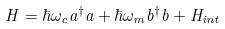Convert formula to latex. <formula><loc_0><loc_0><loc_500><loc_500>H = \hbar { \omega } _ { c } a ^ { \dag } a + \hbar { \omega } _ { m } b ^ { \dag } b + H _ { i n t }</formula> 